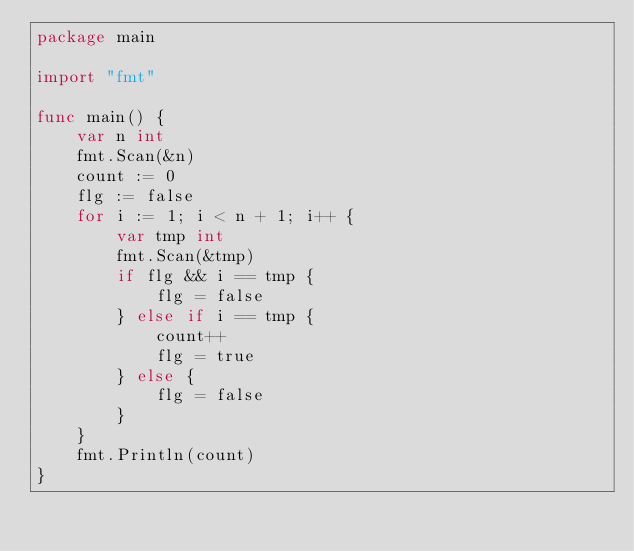Convert code to text. <code><loc_0><loc_0><loc_500><loc_500><_Go_>package main

import "fmt"

func main() {
	var n int
	fmt.Scan(&n)
	count := 0
	flg := false
	for i := 1; i < n + 1; i++ {
		var tmp int
		fmt.Scan(&tmp)
		if flg && i == tmp {
			flg = false
		} else if i == tmp {
			count++
			flg = true
		} else {
			flg = false
		}
	}
	fmt.Println(count)
}</code> 